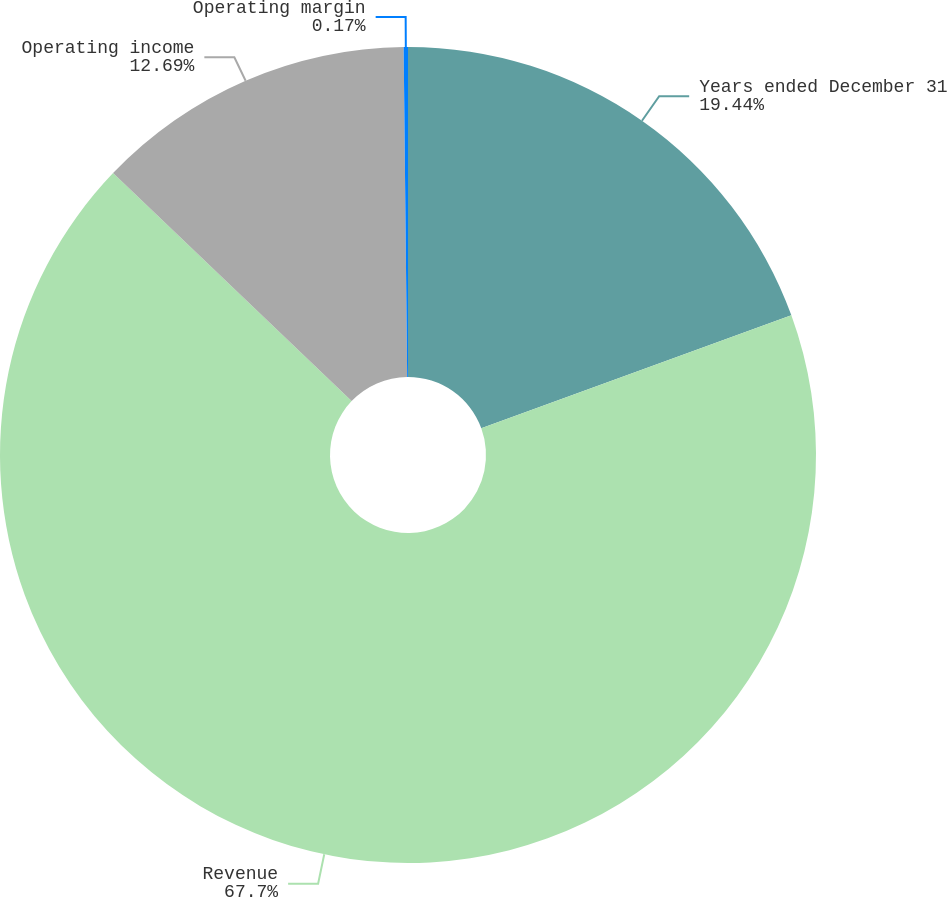Convert chart. <chart><loc_0><loc_0><loc_500><loc_500><pie_chart><fcel>Years ended December 31<fcel>Revenue<fcel>Operating income<fcel>Operating margin<nl><fcel>19.44%<fcel>67.7%<fcel>12.69%<fcel>0.17%<nl></chart> 